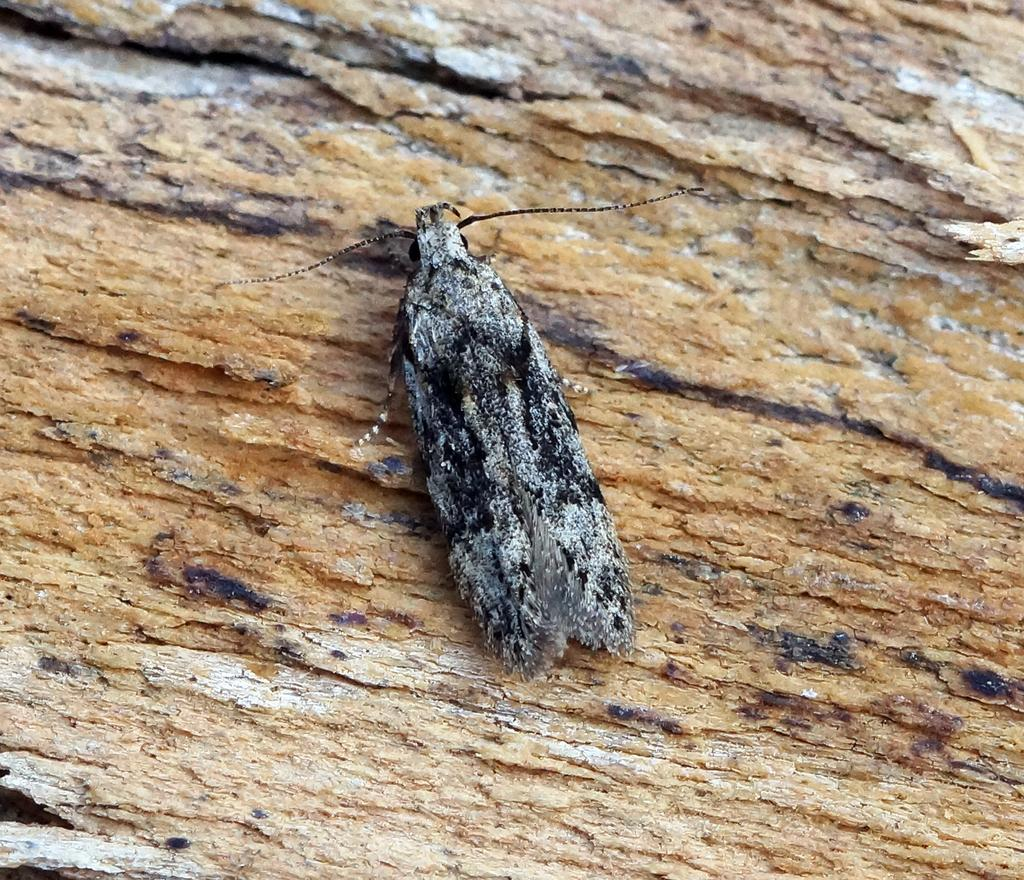What type of creature is in the image? There is an insect in the image. What color is the insect? The insect is black in color. What can be seen in the background of the image? The background of the image appears to be brown. What might the brown background be a part of? The brown background might be the stem of a tree. How much money does the insect have in the image? There is no indication of money or any financial transactions involving the insect in the image. 